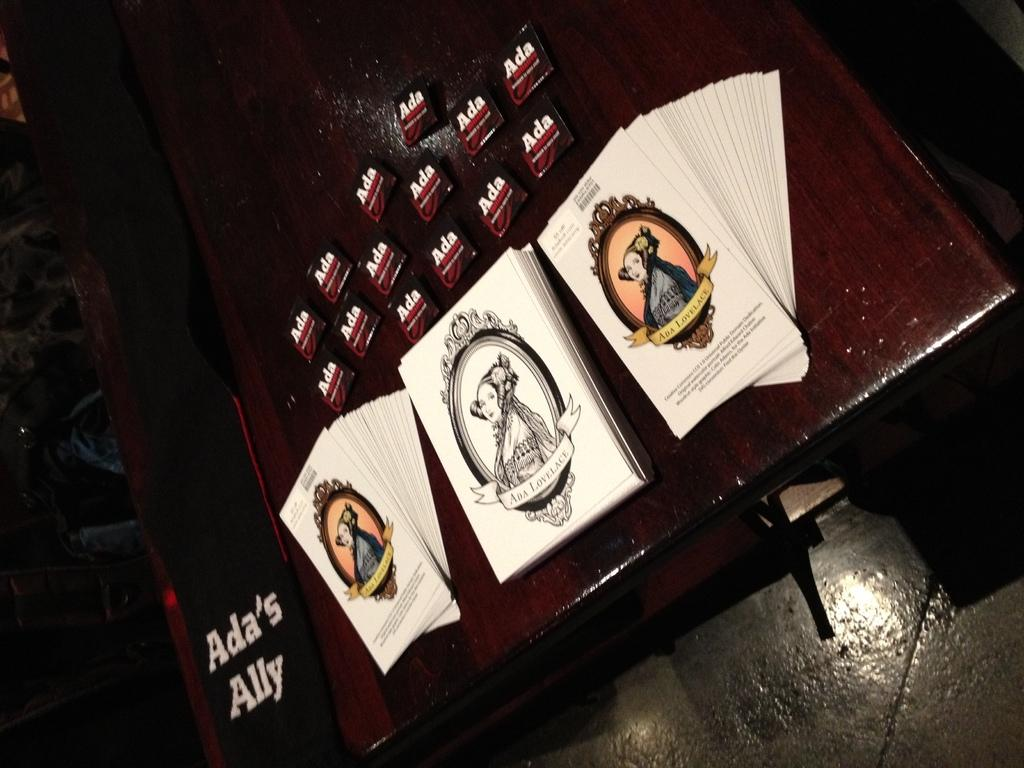What is on the table in the image? There are papers with text and pictures on the table. How would you describe the overall lighting in the image? The background of the image is dark. What type of coal is being used to decorate the papers in the image? There is no coal present in the image, and the papers are not being decorated with coal. How many eggs can be seen on the table in the image? There are no eggs visible on the table in the image. 